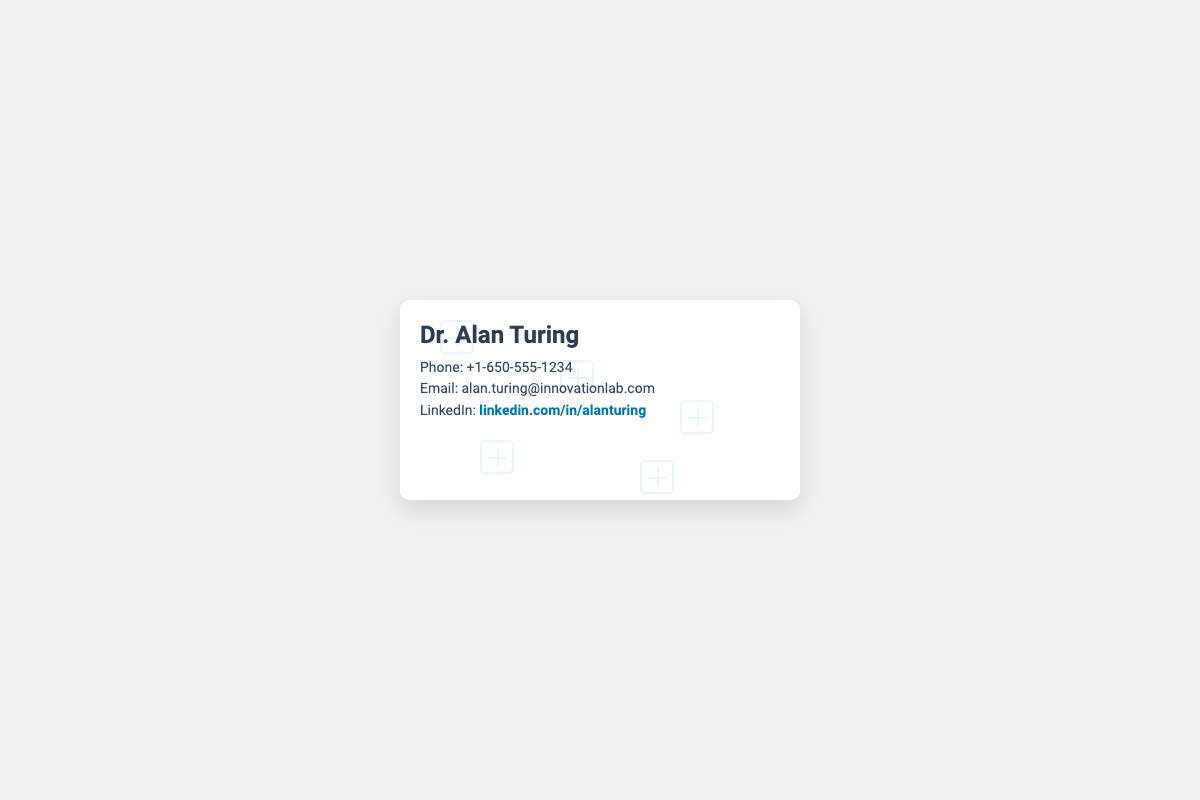What is the name on the business card? The name displayed prominently on the card is 'Dr. Alan Turing'.
Answer: Dr. Alan Turing What is the phone number listed? The phone number is specified in a contact information section on the card.
Answer: +1-650-555-1234 What is the email address mentioned? The email address can be found in the contact information section of the card.
Answer: alan.turing@innovationlab.com What is the LinkedIn link provided? The LinkedIn profile link is included as a clickable reference on the card.
Answer: linkedin.com/in/alanturing How many interconnected microchips are visible in the pattern? The card displays five interconnected microchips in the background pattern.
Answer: 5 What color is the LinkedIn text? The LinkedIn text on the card has a specific color associated with its branding.
Answer: #0077B5 What is the background color of the card? The background color of the card is defined in the card's style attributes.
Answer: White What type of document is this? The document is specifically designed as a business card.
Answer: Business card What font is used for the card content? The font name used in the design is specified in the styling of the document.
Answer: Roboto 